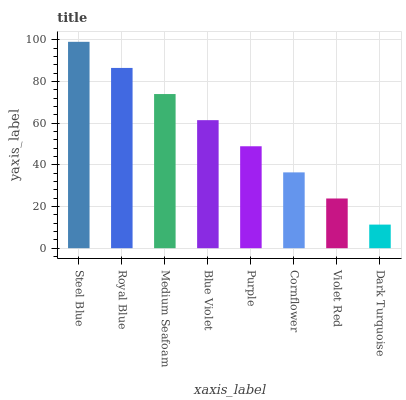Is Dark Turquoise the minimum?
Answer yes or no. Yes. Is Steel Blue the maximum?
Answer yes or no. Yes. Is Royal Blue the minimum?
Answer yes or no. No. Is Royal Blue the maximum?
Answer yes or no. No. Is Steel Blue greater than Royal Blue?
Answer yes or no. Yes. Is Royal Blue less than Steel Blue?
Answer yes or no. Yes. Is Royal Blue greater than Steel Blue?
Answer yes or no. No. Is Steel Blue less than Royal Blue?
Answer yes or no. No. Is Blue Violet the high median?
Answer yes or no. Yes. Is Purple the low median?
Answer yes or no. Yes. Is Violet Red the high median?
Answer yes or no. No. Is Dark Turquoise the low median?
Answer yes or no. No. 